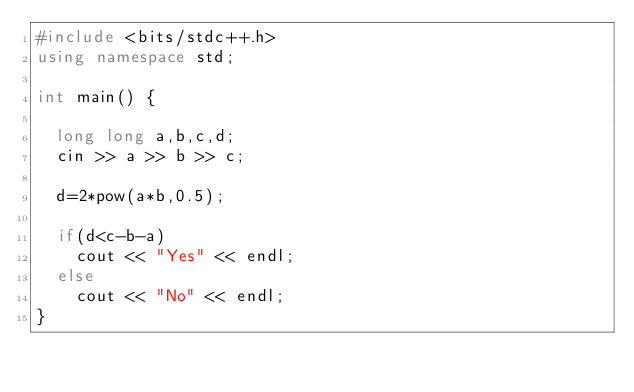<code> <loc_0><loc_0><loc_500><loc_500><_C++_>#include <bits/stdc++.h>
using namespace std;

int main() {
  
  long long a,b,c,d;
  cin >> a >> b >> c;
  
  d=2*pow(a*b,0.5);
    
  if(d<c-b-a)
    cout << "Yes" << endl;
  else
    cout << "No" << endl;
}</code> 